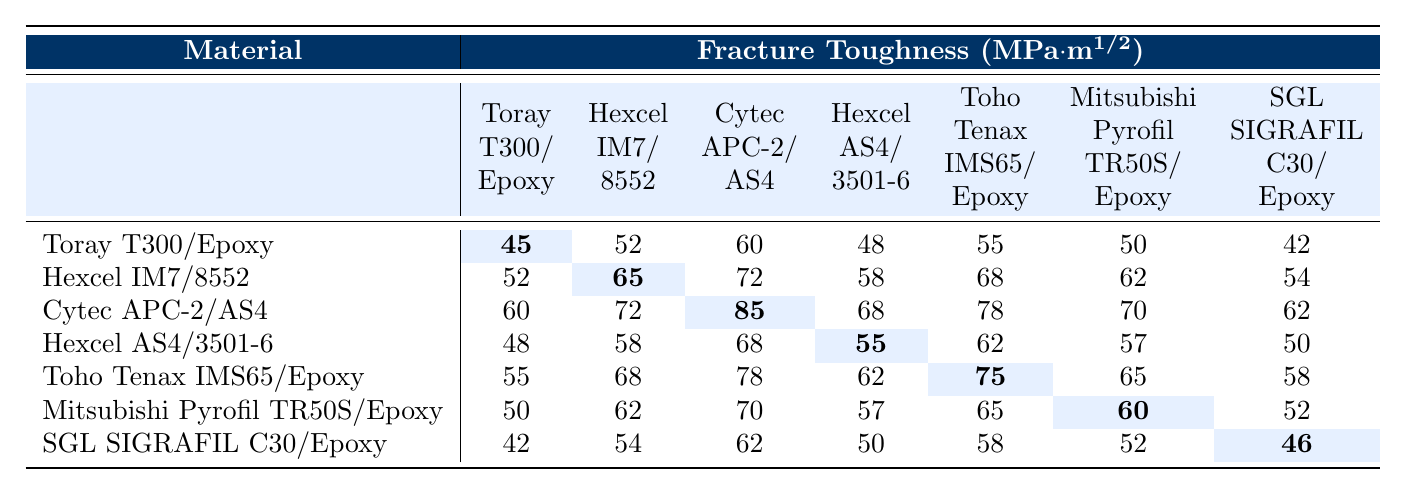What is the fracture toughness value for Cytec APC-2/AS4? The table provides a specific cell for the material Cytec APC-2/AS4 under the Fracture Toughness column, which states 85 MPa·m^1/2.
Answer: 85 MPa·m^1/2 Which material has the highest fracture toughness value? By examining the highest value across the rows of fracture toughness, Cytec APC-2/AS4 shows 85 MPa·m^1/2 as the maximum value in the table.
Answer: Cytec APC-2/AS4 What is the difference in fracture toughness between Hexcel IM7/8552 and SGL SIGRAFIL C30/Epoxy? The fracture toughness for Hexcel IM7/8552 is 65 MPa·m^1/2 and for SGL SIGRAFIL C30/Epoxy is 46 MPa·m^1/2. The difference is 65 - 46 = 19 MPa·m^1/2.
Answer: 19 MPa·m^1/2 What is the average fracture toughness value for all the materials listed? To find the average, sum all the fracture toughness values: 45 + 52 + 60 + 48 + 55 + 50 + 42 + 52 + 65 + 72 + 58 + 68 + 62 + 54 + 60 + 72 + 85 + 68 + 78 + 70 + 62 + 48 + 58 + 68 + 55 + 62 + 57 + 50 + 55 + 68 + 78 + 62 + 75 + 65 + 58 + 50 + 62 + 70 + 57 + 65 + 60 + 52 + 42 + 54 + 62 + 50 + 58 + 52 + 46 = 2244. There are 28 data points, so the average is 2244 / 28 = 80.14.
Answer: 80.14 MPa·m^1/2 Does Hexcel AS4/3501-6 have a higher fracture toughness value than Toray T300/Epoxy? The fracture toughness value for Hexcel AS4/3501-6 is 55 MPa·m^1/2 and for Toray T300/Epoxy is 45 MPa·m^1/2. Since 55 is greater than 45, the statement is true.
Answer: Yes Which material has the second lowest fracture toughness value? From the lowest values listed, SGL SIGRAFIL C30/Epoxy has a value of 46 MPa·m^1/2 and Toray T300/Epoxy has 45 MPa·m^1/2. So, the material with the second lowest is Mitsubishi Pyrofil TR50S/Epoxy with 60 MPa·m^1/2.
Answer: Mitsubishi Pyrofil TR50S/Epoxy How many materials have a fracture toughness value above 70 MPa·m^1/2? The materials meeting this condition are Cytec APC-2/AS4 (85), Hexcel IM7/8552 (72), and Toho Tenax IMS65/Epoxy (78). Therefore, there are 3 materials with a value above 70.
Answer: 3 What is the sum of the fracture toughness values for Mitsubishi Pyrofil TR50S/Epoxy across the given conditions? The fracture toughness values for Mitsubishi Pyrofil TR50S/Epoxy are: 50, 62, 70, 57, 65, 60, 52. The total sum is calculated as 50 + 62 + 70 + 57 + 65 + 60 + 52 = 366.
Answer: 366 MPa·m^1/2 Is there a material that has the same fracture toughness value of 62 MPa·m^1/2 as Hexcel IM7/8552? Looking through the table, both Mitsubishi Pyrofil TR50S/Epoxy and Hexcel AS4/3501-6 have values of 62 MPa·m^1/2. Therefore the answer is yes.
Answer: Yes 